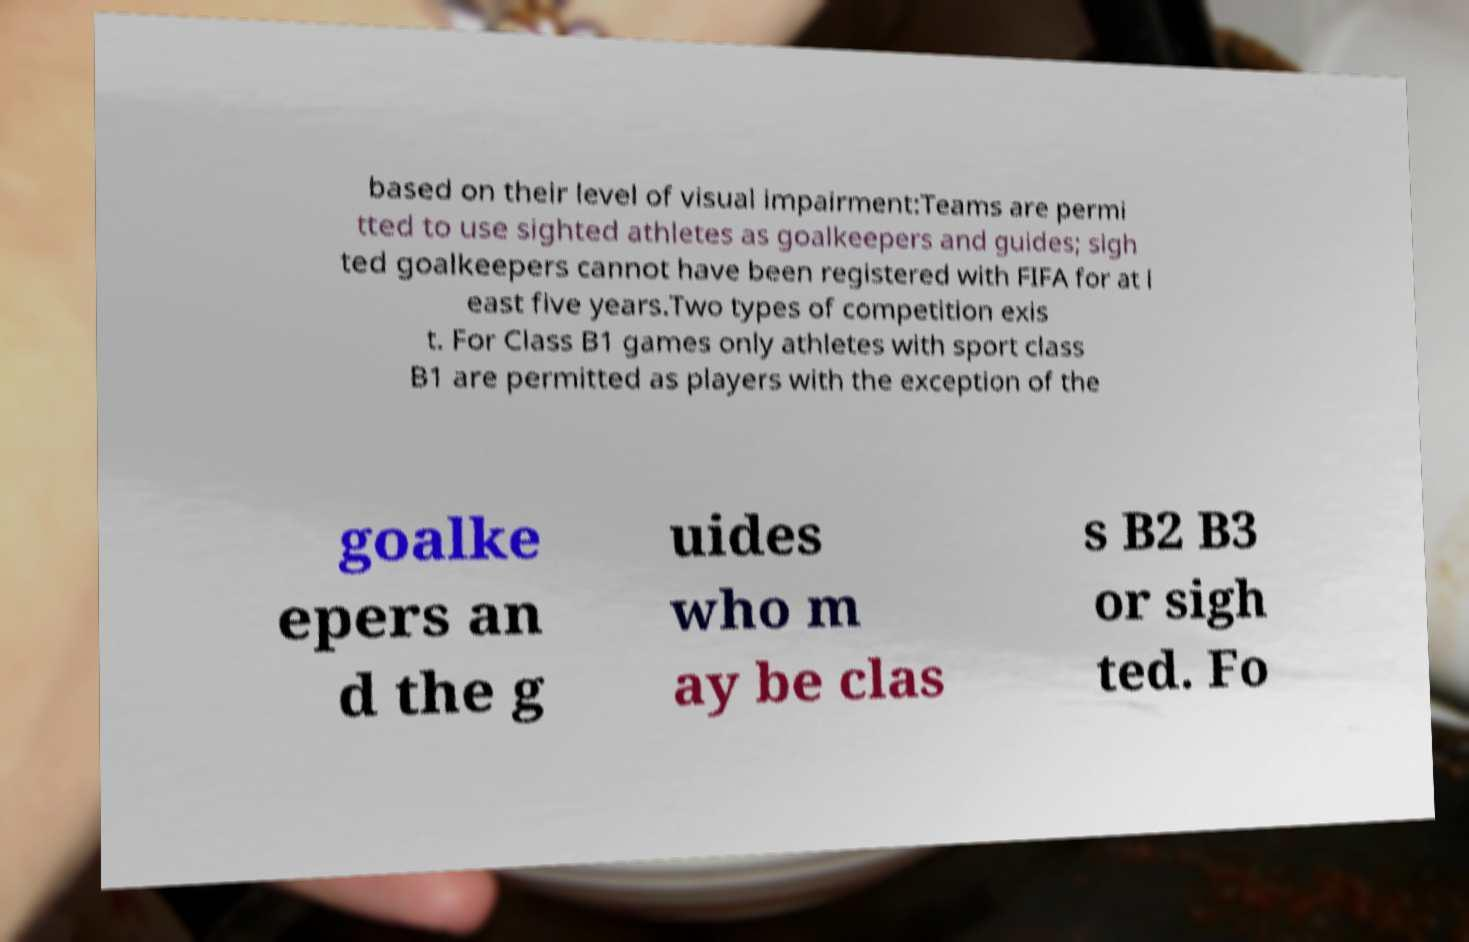Could you assist in decoding the text presented in this image and type it out clearly? based on their level of visual impairment:Teams are permi tted to use sighted athletes as goalkeepers and guides; sigh ted goalkeepers cannot have been registered with FIFA for at l east five years.Two types of competition exis t. For Class B1 games only athletes with sport class B1 are permitted as players with the exception of the goalke epers an d the g uides who m ay be clas s B2 B3 or sigh ted. Fo 